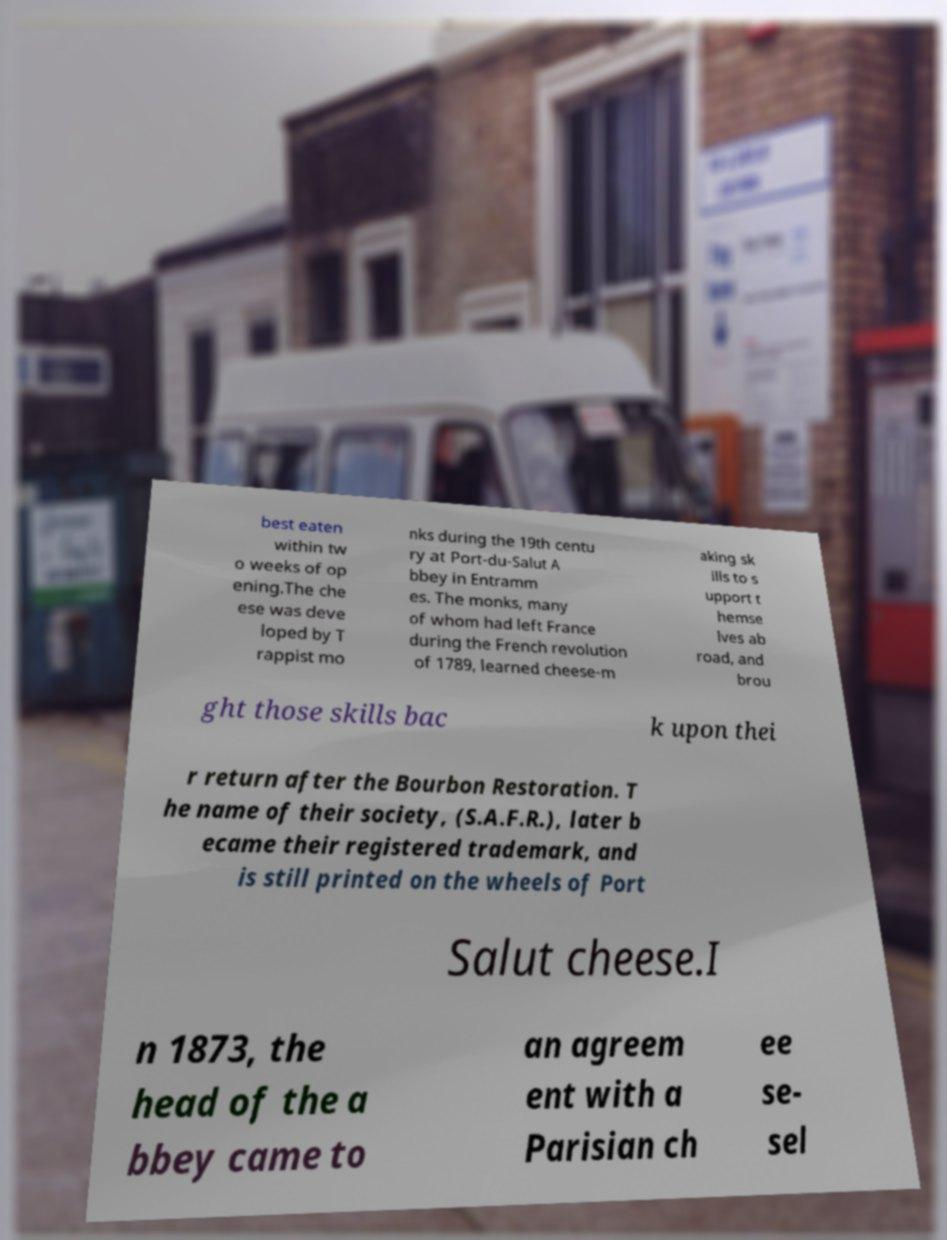What messages or text are displayed in this image? I need them in a readable, typed format. best eaten within tw o weeks of op ening.The che ese was deve loped by T rappist mo nks during the 19th centu ry at Port-du-Salut A bbey in Entramm es. The monks, many of whom had left France during the French revolution of 1789, learned cheese-m aking sk ills to s upport t hemse lves ab road, and brou ght those skills bac k upon thei r return after the Bourbon Restoration. T he name of their society, (S.A.F.R.), later b ecame their registered trademark, and is still printed on the wheels of Port Salut cheese.I n 1873, the head of the a bbey came to an agreem ent with a Parisian ch ee se- sel 